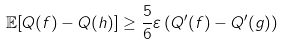<formula> <loc_0><loc_0><loc_500><loc_500>\mathbb { E } [ Q ( f ) - Q ( h ) ] \geq \frac { 5 } { 6 } \varepsilon \left ( Q ^ { \prime } ( f ) - Q ^ { \prime } ( g ) \right )</formula> 